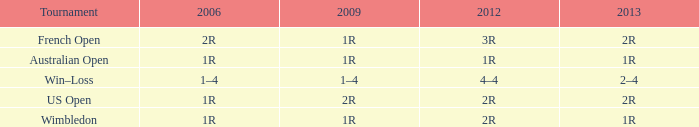What is the 2006 when the 2013 is 1r, and the 2012 is 1r? 1R. 